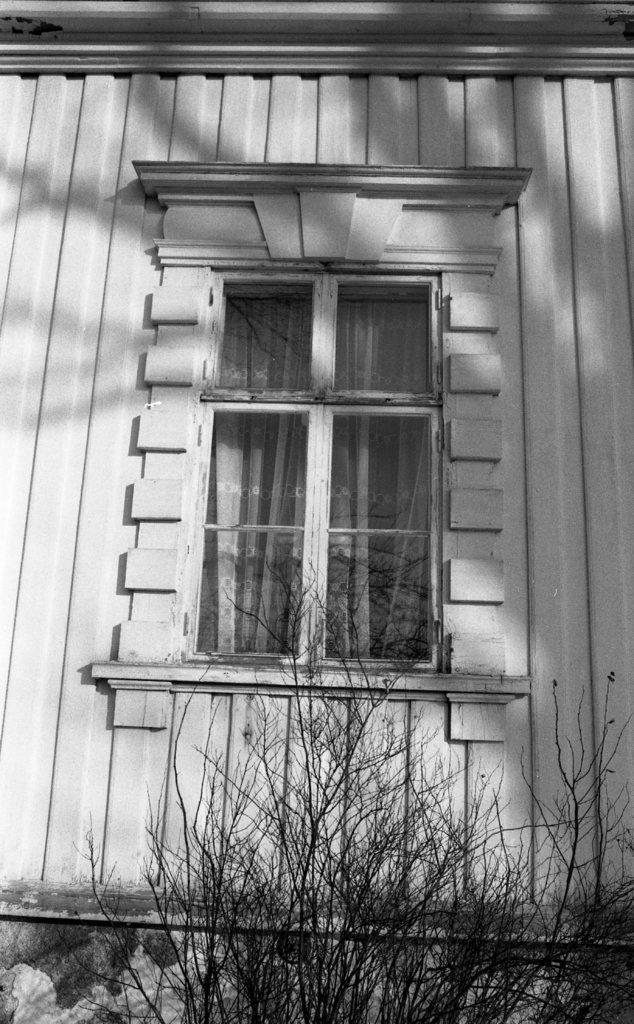What can be seen in the image that provides a view of the outside? There is a window in the image. What is covering or hanging near the window? There is a curtain associated with the window. What type of structure is visible in the image? There is a wall in the image. What type of vegetation is present in the image? There is a dried plant in the image. How many cherries are hanging from the wall in the image? There are no cherries present in the image; it features a window, curtain, wall, and dried plant. What idea is being expressed by the dried plant in the image? The dried plant in the image is not expressing any idea; it is simply a dried plant. 